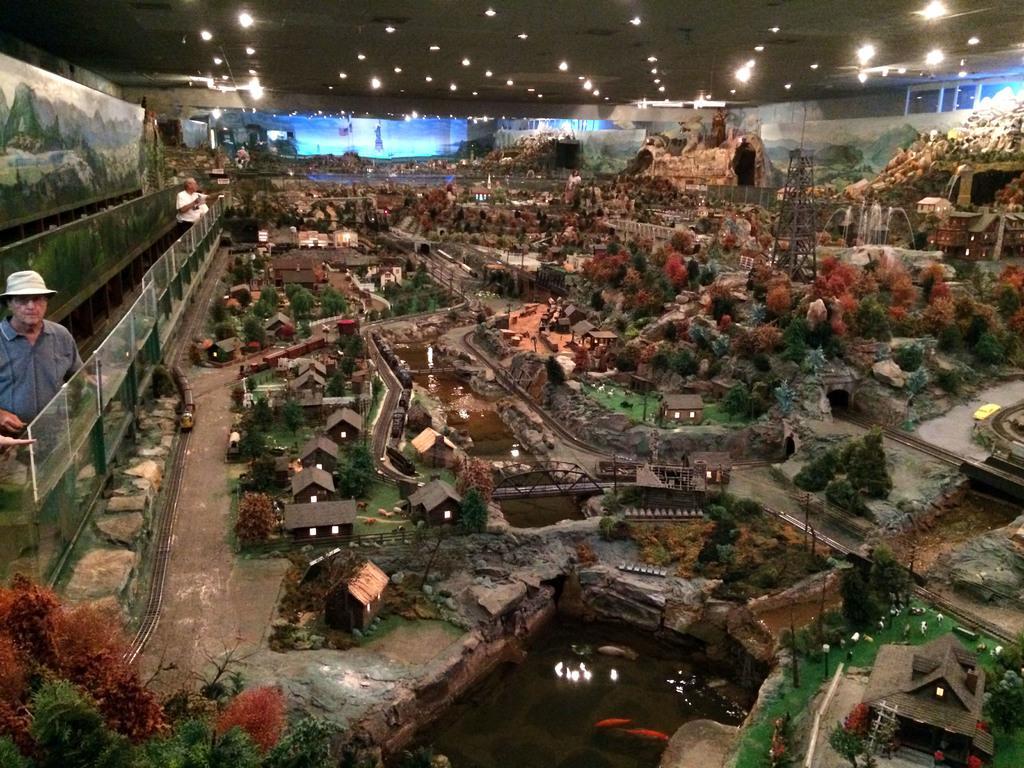Could you give a brief overview of what you see in this image? In this picture there are two people and we can see board, water and fence. We can see miniature of houses, trees, trains, car and tower. In the background of the image we can see lights and screen. 